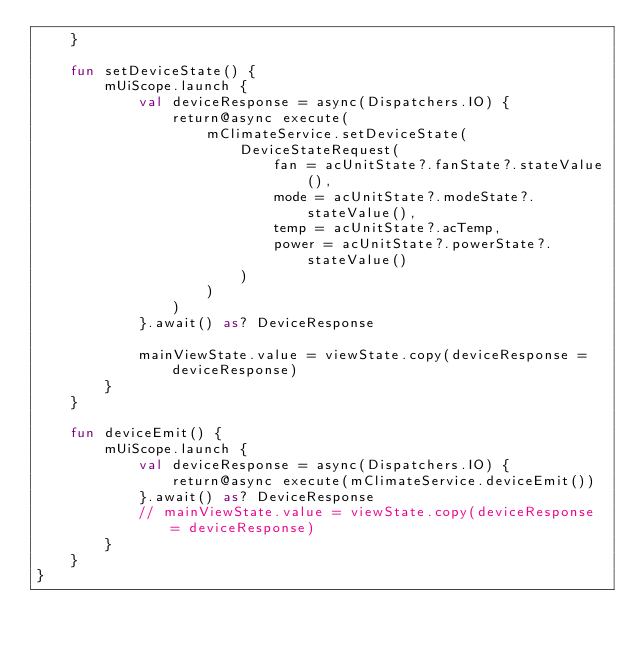Convert code to text. <code><loc_0><loc_0><loc_500><loc_500><_Kotlin_>    }

    fun setDeviceState() {
        mUiScope.launch {
            val deviceResponse = async(Dispatchers.IO) {
                return@async execute(
                    mClimateService.setDeviceState(
                        DeviceStateRequest(
                            fan = acUnitState?.fanState?.stateValue(),
                            mode = acUnitState?.modeState?.stateValue(),
                            temp = acUnitState?.acTemp,
                            power = acUnitState?.powerState?.stateValue()
                        )
                    )
                )
            }.await() as? DeviceResponse

            mainViewState.value = viewState.copy(deviceResponse = deviceResponse)
        }
    }

    fun deviceEmit() {
        mUiScope.launch {
            val deviceResponse = async(Dispatchers.IO) {
                return@async execute(mClimateService.deviceEmit())
            }.await() as? DeviceResponse
            // mainViewState.value = viewState.copy(deviceResponse = deviceResponse)
        }
    }
}</code> 